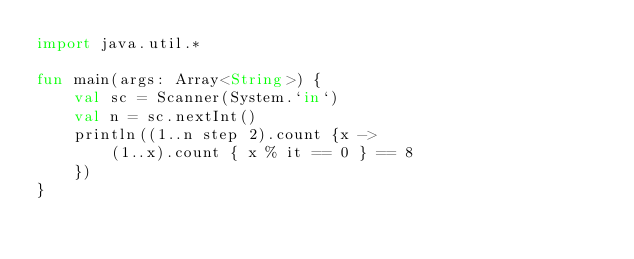<code> <loc_0><loc_0><loc_500><loc_500><_Kotlin_>import java.util.*

fun main(args: Array<String>) {
    val sc = Scanner(System.`in`)
    val n = sc.nextInt()
    println((1..n step 2).count {x ->
        (1..x).count { x % it == 0 } == 8
    })
}</code> 